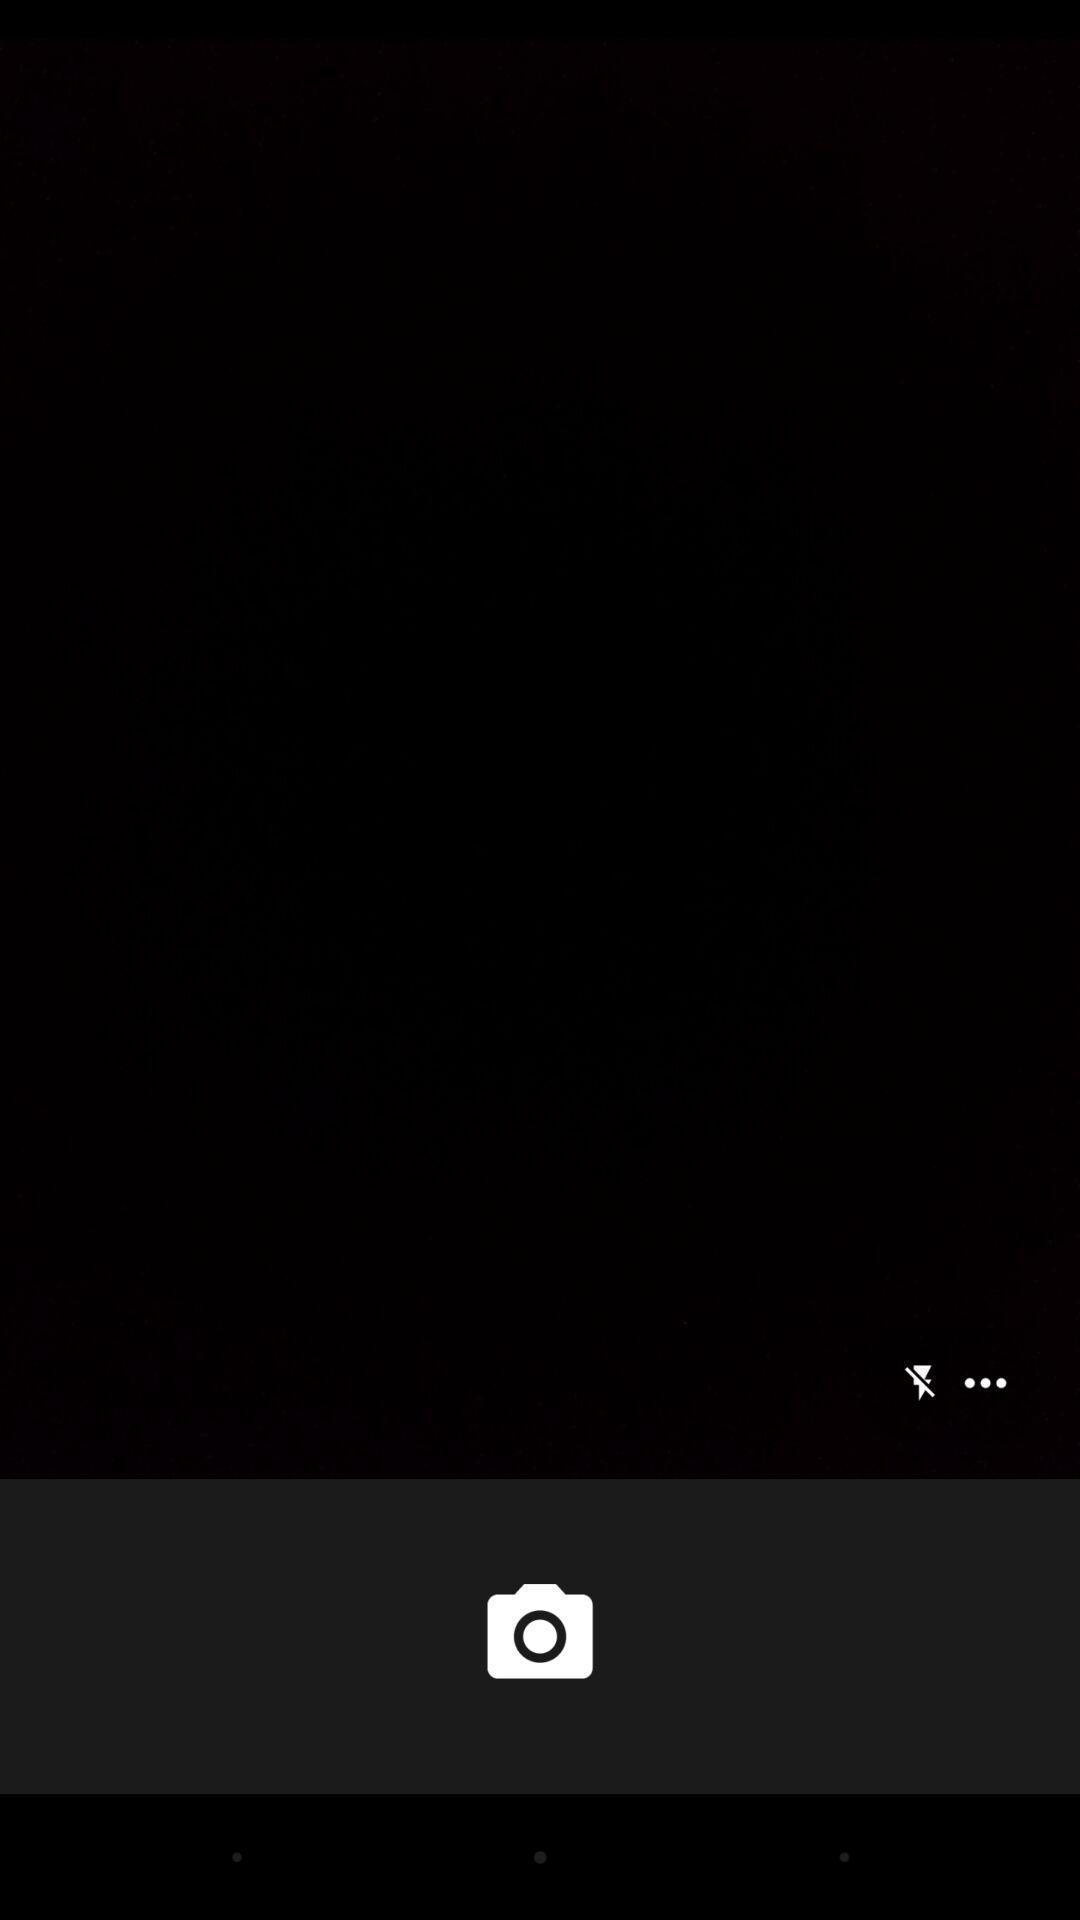Describe the content in this image. Screen displaying the camera and flash icon. 